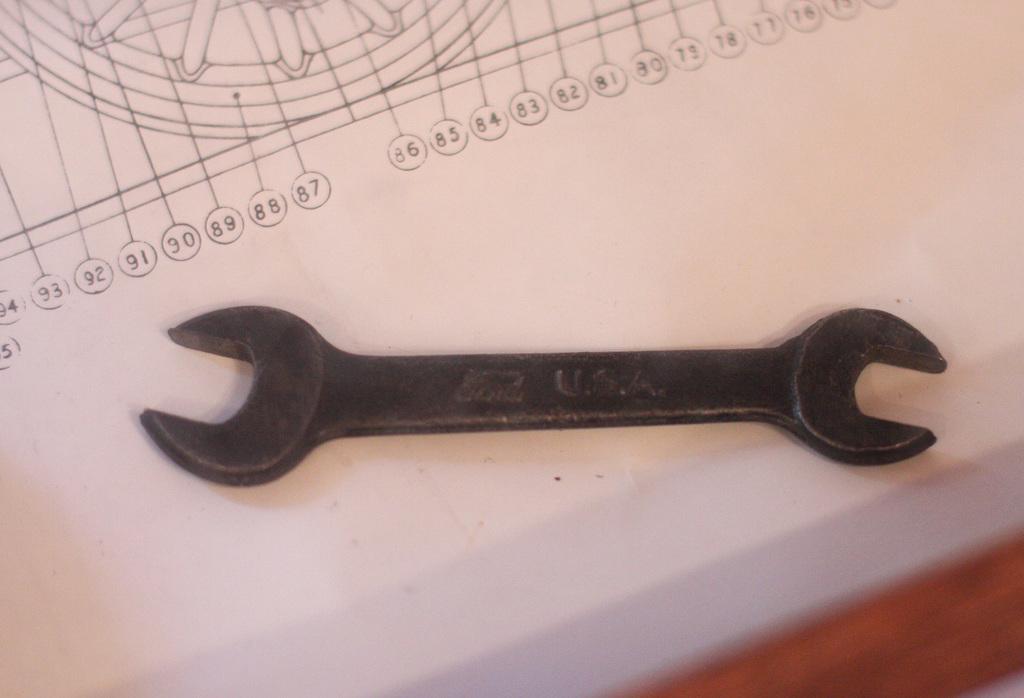Describe this image in one or two sentences. In this picture I can see the wrench which is kept on the paper. At the top I can see the design of a wheel and numbers. In the bottom right there is a table. 